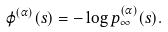Convert formula to latex. <formula><loc_0><loc_0><loc_500><loc_500>\varphi ^ { ( \alpha ) } ( s ) = - \log p ^ { ( \alpha ) } _ { \infty } ( s ) .</formula> 